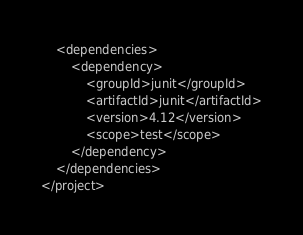Convert code to text. <code><loc_0><loc_0><loc_500><loc_500><_XML_>
    <dependencies>
        <dependency>
            <groupId>junit</groupId>
            <artifactId>junit</artifactId>
            <version>4.12</version>
            <scope>test</scope>
        </dependency>
    </dependencies>
</project></code> 